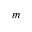Convert formula to latex. <formula><loc_0><loc_0><loc_500><loc_500>m</formula> 